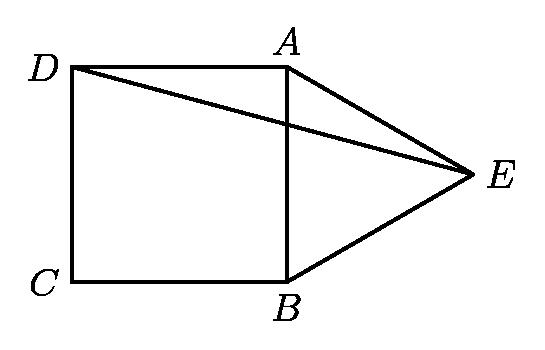In the adjoining figure, $ABCD$ is a square, $ABE$ is an equilateral triangle and point $E$ is outside square $ABCD$. What is the measure of $\measuredangle AED$ in degrees? To determine the measure of angle AED, we can use the properties of the square and the equilateral triangle. Since ABCD is a square, angle AEB is 90 degrees. Because an equilateral triangle has all angles equal, angle ABE is 60 degrees. Subtracting the measure of angle ABE from angle AEB gives us angle AED which is 90 - 60 = 30 degrees. Therefore, the measure of angle AED is 30 degrees. 